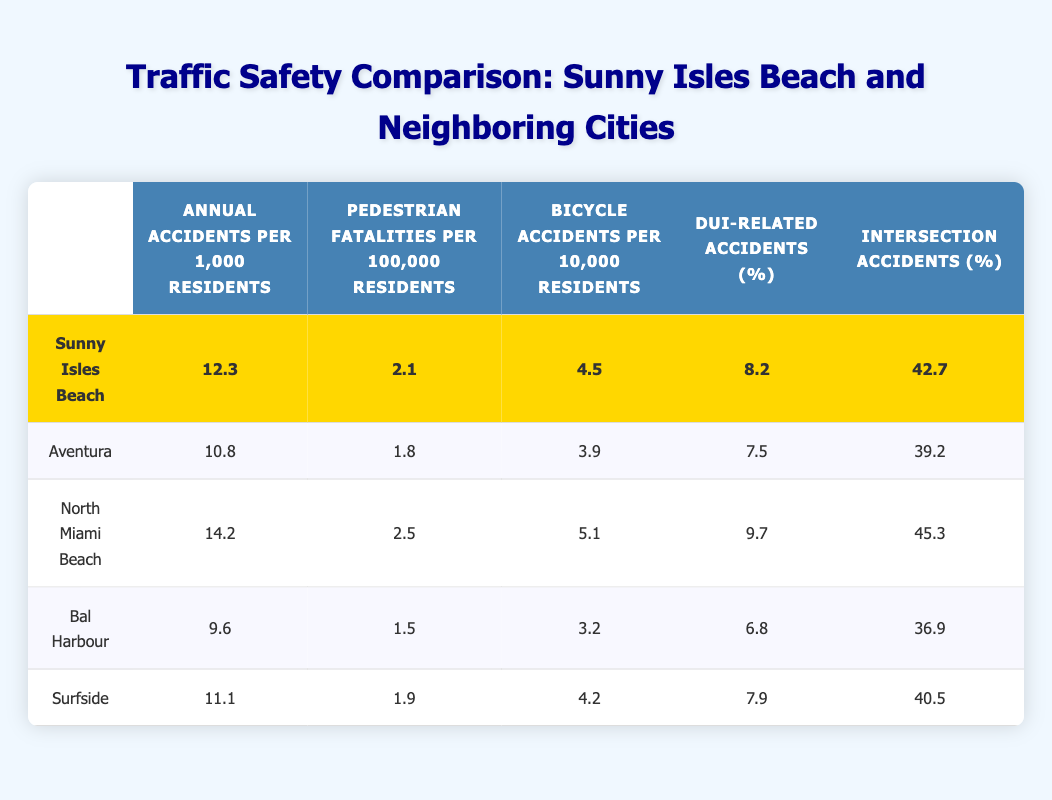What is the annual accident rate per 1,000 residents in Sunny Isles Beach? From the table, the value for "Annual accidents per 1,000 residents" for Sunny Isles Beach is clearly listed as 12.3.
Answer: 12.3 Which city has the highest pedestrian fatalities per 100,000 residents? By comparing the values in the "Pedestrian fatalities per 100,000 residents" column, North Miami Beach has the highest value at 2.5.
Answer: North Miami Beach How many more annual accidents per 1,000 residents does North Miami Beach have compared to Bal Harbour? North Miami Beach has 14.2 and Bal Harbour has 9.6. The difference is calculated as 14.2 - 9.6 = 4.6.
Answer: 4.6 Is the percentage of DUI-related accidents in Sunny Isles Beach higher than in Aventura? Sunny Isles Beach has 8.2% while Aventura has 7.5%. Since 8.2% is greater than 7.5%, the answer is yes.
Answer: Yes What is the average number of bicycle accidents per 10,000 residents across all cities? The values for bicycle accidents are 4.5, 3.9, 5.1, 3.2, and 4.2. The sum is 4.5 + 3.9 + 5.1 + 3.2 + 4.2 = 21. The average is 21 divided by 5 which equals 4.2.
Answer: 4.2 Which city has the lowest intersection accidents percentage? Looking at the "Intersection accidents (%)" column, Bal Harbour has the lowest at 36.9%.
Answer: Bal Harbour How does the average pedestrian fatalities per 100,000 residents for the three cities, Aventura, Bal Harbour, and Surfside, compare to Sunny Isles Beach? The values for those cities are 1.8 (Aventura), 1.5 (Bal Harbour), and 1.9 (Surfside). Their average is (1.8 + 1.5 + 1.9) / 3 = 1.733. Comparing this to Sunny Isles Beach's 2.1 shows that Sunny Isles Beach has higher fatalities.
Answer: Sunny Isles Beach is higher Is it true that Surfside has more bicycle accidents per 10,000 residents than Aventura? The values are 4.2 (Surfside) and 3.9 (Aventura). Since 4.2 is greater than 3.9, the statement is true.
Answer: Yes 